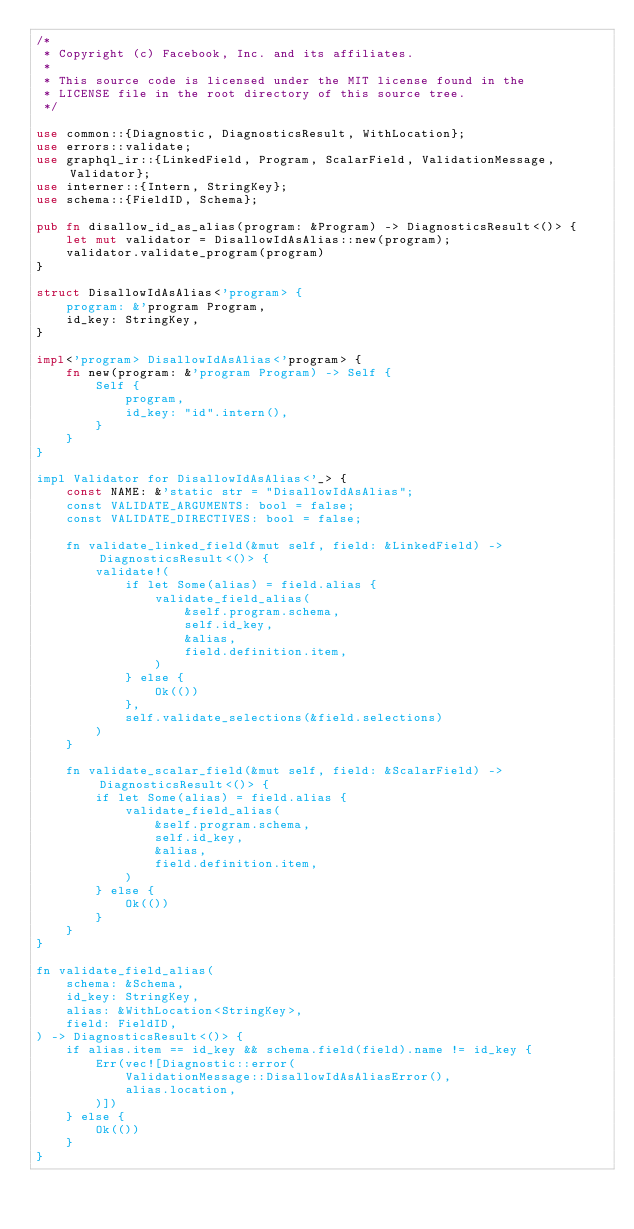Convert code to text. <code><loc_0><loc_0><loc_500><loc_500><_Rust_>/*
 * Copyright (c) Facebook, Inc. and its affiliates.
 *
 * This source code is licensed under the MIT license found in the
 * LICENSE file in the root directory of this source tree.
 */

use common::{Diagnostic, DiagnosticsResult, WithLocation};
use errors::validate;
use graphql_ir::{LinkedField, Program, ScalarField, ValidationMessage, Validator};
use interner::{Intern, StringKey};
use schema::{FieldID, Schema};

pub fn disallow_id_as_alias(program: &Program) -> DiagnosticsResult<()> {
    let mut validator = DisallowIdAsAlias::new(program);
    validator.validate_program(program)
}

struct DisallowIdAsAlias<'program> {
    program: &'program Program,
    id_key: StringKey,
}

impl<'program> DisallowIdAsAlias<'program> {
    fn new(program: &'program Program) -> Self {
        Self {
            program,
            id_key: "id".intern(),
        }
    }
}

impl Validator for DisallowIdAsAlias<'_> {
    const NAME: &'static str = "DisallowIdAsAlias";
    const VALIDATE_ARGUMENTS: bool = false;
    const VALIDATE_DIRECTIVES: bool = false;

    fn validate_linked_field(&mut self, field: &LinkedField) -> DiagnosticsResult<()> {
        validate!(
            if let Some(alias) = field.alias {
                validate_field_alias(
                    &self.program.schema,
                    self.id_key,
                    &alias,
                    field.definition.item,
                )
            } else {
                Ok(())
            },
            self.validate_selections(&field.selections)
        )
    }

    fn validate_scalar_field(&mut self, field: &ScalarField) -> DiagnosticsResult<()> {
        if let Some(alias) = field.alias {
            validate_field_alias(
                &self.program.schema,
                self.id_key,
                &alias,
                field.definition.item,
            )
        } else {
            Ok(())
        }
    }
}

fn validate_field_alias(
    schema: &Schema,
    id_key: StringKey,
    alias: &WithLocation<StringKey>,
    field: FieldID,
) -> DiagnosticsResult<()> {
    if alias.item == id_key && schema.field(field).name != id_key {
        Err(vec![Diagnostic::error(
            ValidationMessage::DisallowIdAsAliasError(),
            alias.location,
        )])
    } else {
        Ok(())
    }
}
</code> 